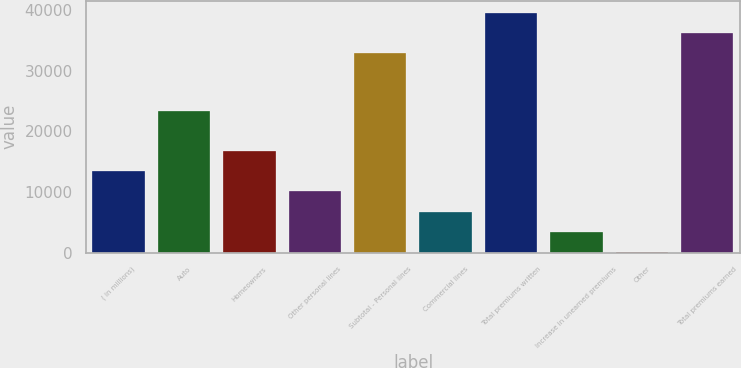<chart> <loc_0><loc_0><loc_500><loc_500><bar_chart><fcel>( in millions)<fcel>Auto<fcel>Homeowners<fcel>Other personal lines<fcel>Subtotal - Personal lines<fcel>Commercial lines<fcel>Total premiums written<fcel>Increase in unearned premiums<fcel>Other<fcel>Total premiums earned<nl><fcel>13458.6<fcel>23367<fcel>16808<fcel>10109.2<fcel>32896<fcel>6759.8<fcel>39594.8<fcel>3410.4<fcel>61<fcel>36245.4<nl></chart> 